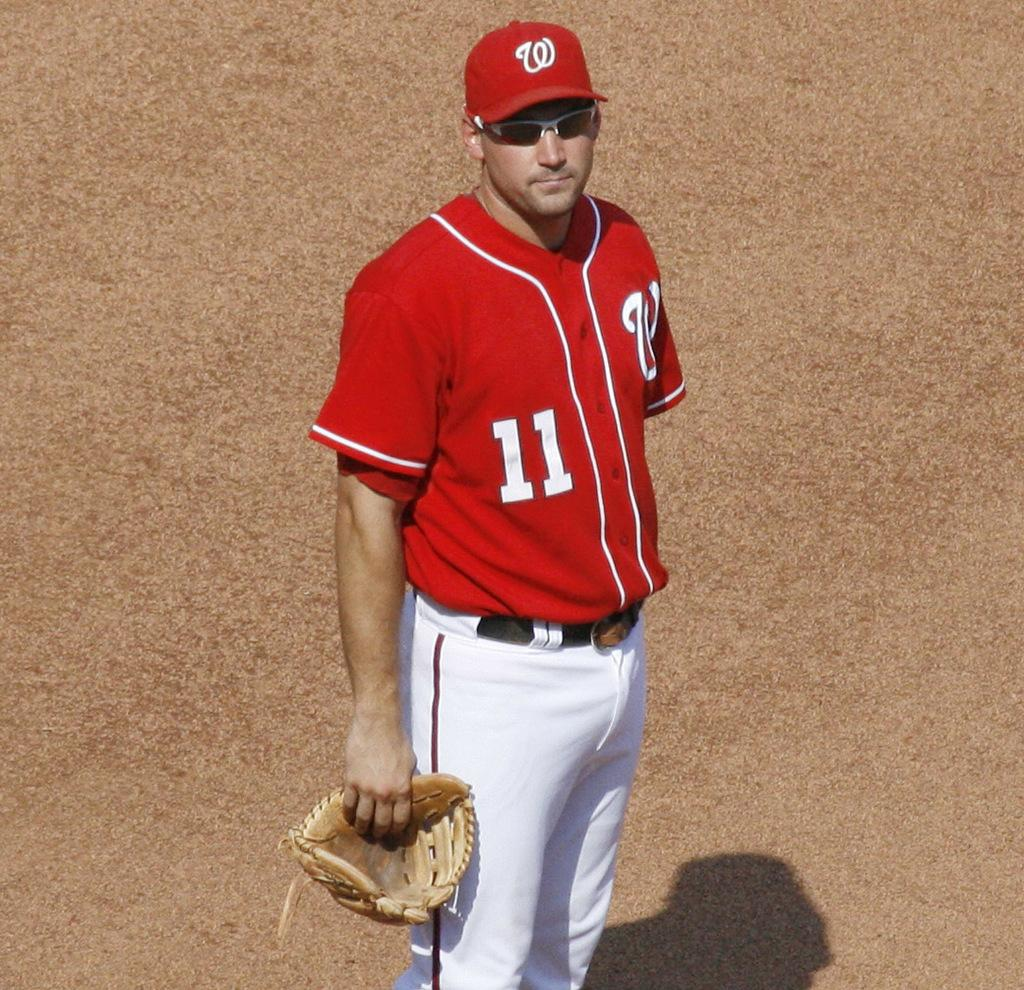<image>
Summarize the visual content of the image. A baseball player with a red jersey that sports a number 11 and a W. 